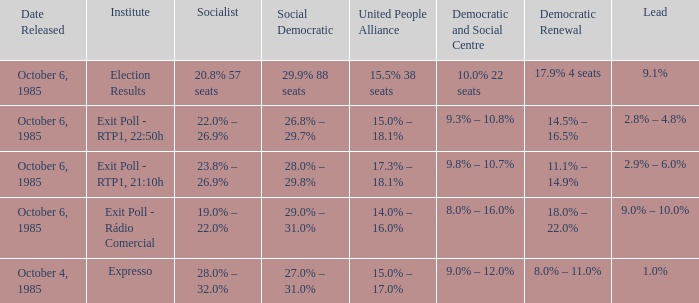Which institutes gave the democratic renewal 18.0% – 22.0% on a poll from october 6, 1985? Exit Poll - Rádio Comercial. 